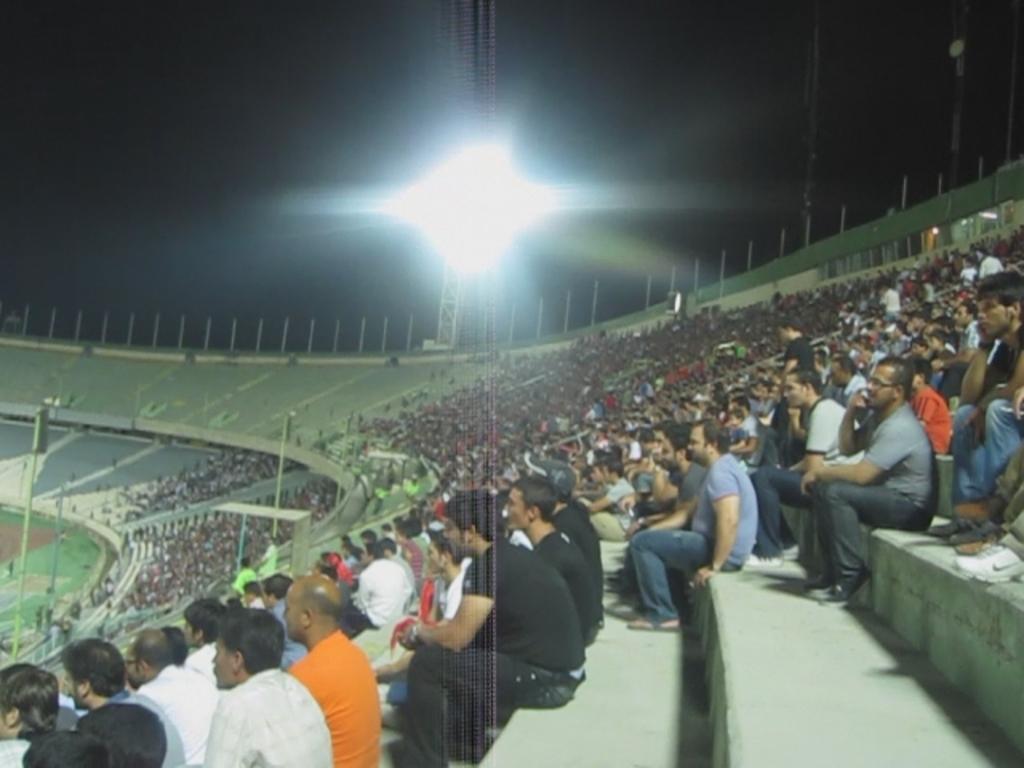Could you give a brief overview of what you see in this image? The picture is clicked in a stadium. In the foreground of the picture there are people and staircase. In the background there are flood lights. Sky is dark. 